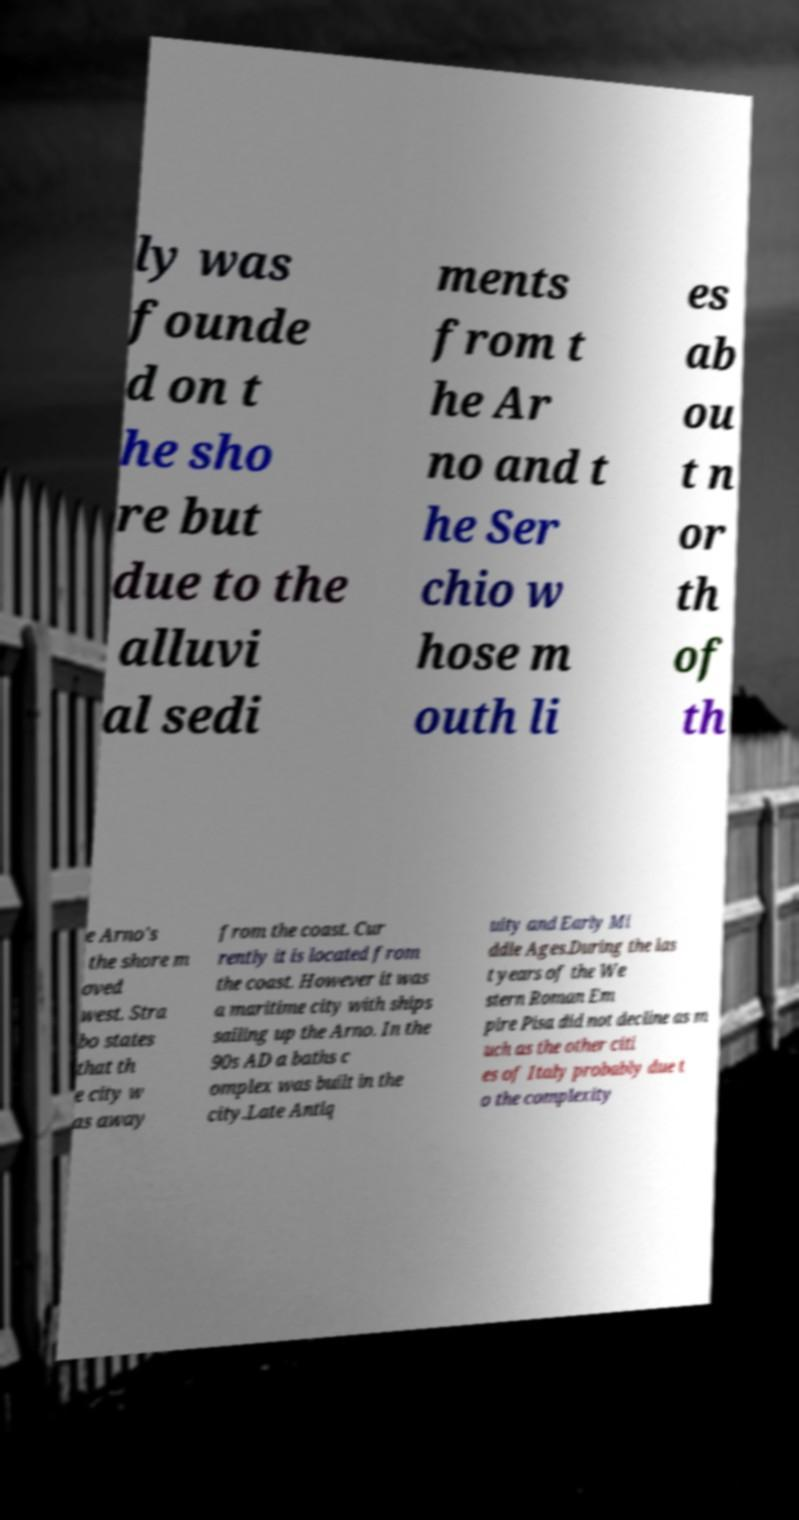Can you accurately transcribe the text from the provided image for me? ly was founde d on t he sho re but due to the alluvi al sedi ments from t he Ar no and t he Ser chio w hose m outh li es ab ou t n or th of th e Arno's the shore m oved west. Stra bo states that th e city w as away from the coast. Cur rently it is located from the coast. However it was a maritime city with ships sailing up the Arno. In the 90s AD a baths c omplex was built in the city.Late Antiq uity and Early Mi ddle Ages.During the las t years of the We stern Roman Em pire Pisa did not decline as m uch as the other citi es of Italy probably due t o the complexity 